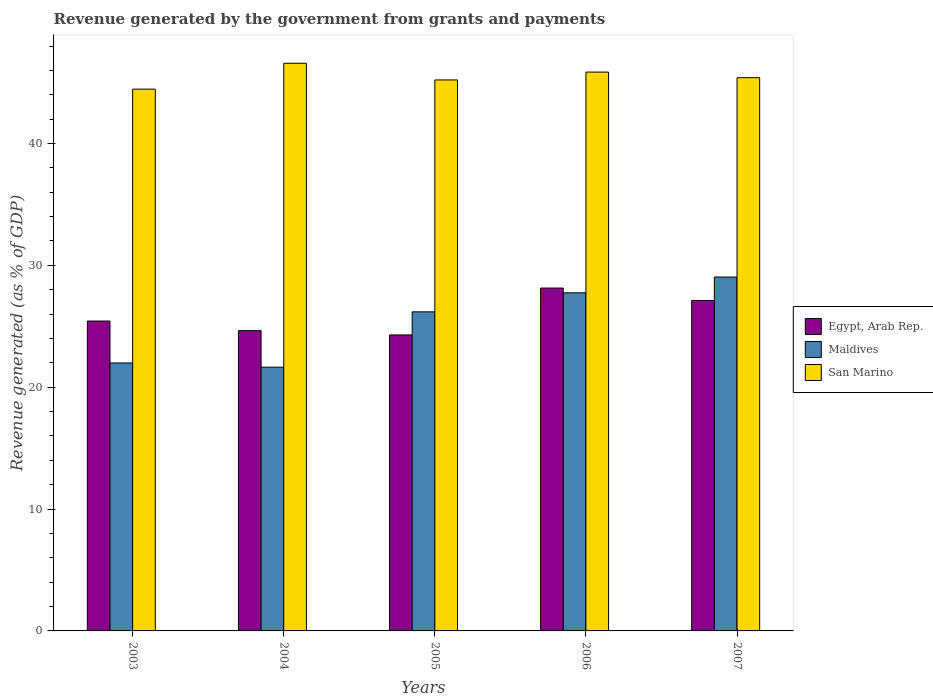Are the number of bars per tick equal to the number of legend labels?
Ensure brevity in your answer.  Yes. How many bars are there on the 5th tick from the left?
Your answer should be compact. 3. How many bars are there on the 5th tick from the right?
Provide a short and direct response. 3. What is the label of the 5th group of bars from the left?
Provide a short and direct response. 2007. In how many cases, is the number of bars for a given year not equal to the number of legend labels?
Give a very brief answer. 0. What is the revenue generated by the government in San Marino in 2007?
Ensure brevity in your answer.  45.4. Across all years, what is the maximum revenue generated by the government in Maldives?
Your answer should be compact. 29.04. Across all years, what is the minimum revenue generated by the government in San Marino?
Ensure brevity in your answer.  44.46. In which year was the revenue generated by the government in San Marino minimum?
Provide a succinct answer. 2003. What is the total revenue generated by the government in Egypt, Arab Rep. in the graph?
Provide a succinct answer. 129.62. What is the difference between the revenue generated by the government in Maldives in 2004 and that in 2005?
Your response must be concise. -4.54. What is the difference between the revenue generated by the government in San Marino in 2003 and the revenue generated by the government in Maldives in 2006?
Ensure brevity in your answer.  16.72. What is the average revenue generated by the government in Maldives per year?
Offer a very short reply. 25.32. In the year 2007, what is the difference between the revenue generated by the government in San Marino and revenue generated by the government in Maldives?
Your response must be concise. 16.36. What is the ratio of the revenue generated by the government in San Marino in 2005 to that in 2007?
Give a very brief answer. 1. What is the difference between the highest and the second highest revenue generated by the government in San Marino?
Ensure brevity in your answer.  0.72. What is the difference between the highest and the lowest revenue generated by the government in San Marino?
Provide a short and direct response. 2.12. What does the 2nd bar from the left in 2005 represents?
Offer a terse response. Maldives. What does the 2nd bar from the right in 2006 represents?
Give a very brief answer. Maldives. How many bars are there?
Give a very brief answer. 15. Are all the bars in the graph horizontal?
Offer a very short reply. No. Are the values on the major ticks of Y-axis written in scientific E-notation?
Offer a terse response. No. Does the graph contain grids?
Offer a very short reply. No. Where does the legend appear in the graph?
Your answer should be compact. Center right. How are the legend labels stacked?
Offer a very short reply. Vertical. What is the title of the graph?
Ensure brevity in your answer.  Revenue generated by the government from grants and payments. Does "Luxembourg" appear as one of the legend labels in the graph?
Offer a terse response. No. What is the label or title of the Y-axis?
Offer a very short reply. Revenue generated (as % of GDP). What is the Revenue generated (as % of GDP) of Egypt, Arab Rep. in 2003?
Your answer should be very brief. 25.43. What is the Revenue generated (as % of GDP) of Maldives in 2003?
Give a very brief answer. 21.99. What is the Revenue generated (as % of GDP) of San Marino in 2003?
Give a very brief answer. 44.46. What is the Revenue generated (as % of GDP) of Egypt, Arab Rep. in 2004?
Your answer should be compact. 24.64. What is the Revenue generated (as % of GDP) of Maldives in 2004?
Make the answer very short. 21.65. What is the Revenue generated (as % of GDP) in San Marino in 2004?
Provide a succinct answer. 46.59. What is the Revenue generated (as % of GDP) in Egypt, Arab Rep. in 2005?
Your answer should be compact. 24.29. What is the Revenue generated (as % of GDP) in Maldives in 2005?
Keep it short and to the point. 26.19. What is the Revenue generated (as % of GDP) in San Marino in 2005?
Provide a succinct answer. 45.22. What is the Revenue generated (as % of GDP) of Egypt, Arab Rep. in 2006?
Ensure brevity in your answer.  28.14. What is the Revenue generated (as % of GDP) of Maldives in 2006?
Your response must be concise. 27.75. What is the Revenue generated (as % of GDP) of San Marino in 2006?
Your answer should be very brief. 45.86. What is the Revenue generated (as % of GDP) in Egypt, Arab Rep. in 2007?
Provide a succinct answer. 27.12. What is the Revenue generated (as % of GDP) of Maldives in 2007?
Give a very brief answer. 29.04. What is the Revenue generated (as % of GDP) of San Marino in 2007?
Offer a very short reply. 45.4. Across all years, what is the maximum Revenue generated (as % of GDP) in Egypt, Arab Rep.?
Keep it short and to the point. 28.14. Across all years, what is the maximum Revenue generated (as % of GDP) in Maldives?
Offer a terse response. 29.04. Across all years, what is the maximum Revenue generated (as % of GDP) in San Marino?
Provide a succinct answer. 46.59. Across all years, what is the minimum Revenue generated (as % of GDP) in Egypt, Arab Rep.?
Provide a succinct answer. 24.29. Across all years, what is the minimum Revenue generated (as % of GDP) in Maldives?
Make the answer very short. 21.65. Across all years, what is the minimum Revenue generated (as % of GDP) in San Marino?
Offer a very short reply. 44.46. What is the total Revenue generated (as % of GDP) in Egypt, Arab Rep. in the graph?
Your answer should be very brief. 129.62. What is the total Revenue generated (as % of GDP) in Maldives in the graph?
Provide a succinct answer. 126.61. What is the total Revenue generated (as % of GDP) of San Marino in the graph?
Make the answer very short. 227.53. What is the difference between the Revenue generated (as % of GDP) of Egypt, Arab Rep. in 2003 and that in 2004?
Offer a very short reply. 0.79. What is the difference between the Revenue generated (as % of GDP) of Maldives in 2003 and that in 2004?
Your answer should be very brief. 0.34. What is the difference between the Revenue generated (as % of GDP) in San Marino in 2003 and that in 2004?
Ensure brevity in your answer.  -2.12. What is the difference between the Revenue generated (as % of GDP) of Egypt, Arab Rep. in 2003 and that in 2005?
Offer a terse response. 1.14. What is the difference between the Revenue generated (as % of GDP) of Maldives in 2003 and that in 2005?
Provide a short and direct response. -4.2. What is the difference between the Revenue generated (as % of GDP) of San Marino in 2003 and that in 2005?
Keep it short and to the point. -0.76. What is the difference between the Revenue generated (as % of GDP) of Egypt, Arab Rep. in 2003 and that in 2006?
Keep it short and to the point. -2.71. What is the difference between the Revenue generated (as % of GDP) of Maldives in 2003 and that in 2006?
Make the answer very short. -5.76. What is the difference between the Revenue generated (as % of GDP) in San Marino in 2003 and that in 2006?
Ensure brevity in your answer.  -1.4. What is the difference between the Revenue generated (as % of GDP) of Egypt, Arab Rep. in 2003 and that in 2007?
Keep it short and to the point. -1.69. What is the difference between the Revenue generated (as % of GDP) of Maldives in 2003 and that in 2007?
Offer a very short reply. -7.05. What is the difference between the Revenue generated (as % of GDP) in San Marino in 2003 and that in 2007?
Your answer should be very brief. -0.94. What is the difference between the Revenue generated (as % of GDP) of Egypt, Arab Rep. in 2004 and that in 2005?
Give a very brief answer. 0.35. What is the difference between the Revenue generated (as % of GDP) in Maldives in 2004 and that in 2005?
Offer a terse response. -4.54. What is the difference between the Revenue generated (as % of GDP) of San Marino in 2004 and that in 2005?
Your answer should be compact. 1.37. What is the difference between the Revenue generated (as % of GDP) of Egypt, Arab Rep. in 2004 and that in 2006?
Offer a very short reply. -3.5. What is the difference between the Revenue generated (as % of GDP) of Maldives in 2004 and that in 2006?
Provide a succinct answer. -6.1. What is the difference between the Revenue generated (as % of GDP) in San Marino in 2004 and that in 2006?
Offer a very short reply. 0.72. What is the difference between the Revenue generated (as % of GDP) in Egypt, Arab Rep. in 2004 and that in 2007?
Offer a very short reply. -2.48. What is the difference between the Revenue generated (as % of GDP) in Maldives in 2004 and that in 2007?
Keep it short and to the point. -7.4. What is the difference between the Revenue generated (as % of GDP) in San Marino in 2004 and that in 2007?
Make the answer very short. 1.18. What is the difference between the Revenue generated (as % of GDP) in Egypt, Arab Rep. in 2005 and that in 2006?
Give a very brief answer. -3.85. What is the difference between the Revenue generated (as % of GDP) of Maldives in 2005 and that in 2006?
Make the answer very short. -1.56. What is the difference between the Revenue generated (as % of GDP) in San Marino in 2005 and that in 2006?
Keep it short and to the point. -0.64. What is the difference between the Revenue generated (as % of GDP) in Egypt, Arab Rep. in 2005 and that in 2007?
Provide a short and direct response. -2.83. What is the difference between the Revenue generated (as % of GDP) in Maldives in 2005 and that in 2007?
Provide a succinct answer. -2.86. What is the difference between the Revenue generated (as % of GDP) of San Marino in 2005 and that in 2007?
Your answer should be very brief. -0.19. What is the difference between the Revenue generated (as % of GDP) of Egypt, Arab Rep. in 2006 and that in 2007?
Your response must be concise. 1.02. What is the difference between the Revenue generated (as % of GDP) of Maldives in 2006 and that in 2007?
Your response must be concise. -1.3. What is the difference between the Revenue generated (as % of GDP) in San Marino in 2006 and that in 2007?
Your response must be concise. 0.46. What is the difference between the Revenue generated (as % of GDP) in Egypt, Arab Rep. in 2003 and the Revenue generated (as % of GDP) in Maldives in 2004?
Your answer should be compact. 3.78. What is the difference between the Revenue generated (as % of GDP) of Egypt, Arab Rep. in 2003 and the Revenue generated (as % of GDP) of San Marino in 2004?
Give a very brief answer. -21.16. What is the difference between the Revenue generated (as % of GDP) in Maldives in 2003 and the Revenue generated (as % of GDP) in San Marino in 2004?
Your answer should be very brief. -24.6. What is the difference between the Revenue generated (as % of GDP) of Egypt, Arab Rep. in 2003 and the Revenue generated (as % of GDP) of Maldives in 2005?
Keep it short and to the point. -0.75. What is the difference between the Revenue generated (as % of GDP) in Egypt, Arab Rep. in 2003 and the Revenue generated (as % of GDP) in San Marino in 2005?
Keep it short and to the point. -19.79. What is the difference between the Revenue generated (as % of GDP) of Maldives in 2003 and the Revenue generated (as % of GDP) of San Marino in 2005?
Give a very brief answer. -23.23. What is the difference between the Revenue generated (as % of GDP) of Egypt, Arab Rep. in 2003 and the Revenue generated (as % of GDP) of Maldives in 2006?
Provide a succinct answer. -2.31. What is the difference between the Revenue generated (as % of GDP) of Egypt, Arab Rep. in 2003 and the Revenue generated (as % of GDP) of San Marino in 2006?
Give a very brief answer. -20.43. What is the difference between the Revenue generated (as % of GDP) in Maldives in 2003 and the Revenue generated (as % of GDP) in San Marino in 2006?
Your answer should be compact. -23.87. What is the difference between the Revenue generated (as % of GDP) of Egypt, Arab Rep. in 2003 and the Revenue generated (as % of GDP) of Maldives in 2007?
Offer a very short reply. -3.61. What is the difference between the Revenue generated (as % of GDP) of Egypt, Arab Rep. in 2003 and the Revenue generated (as % of GDP) of San Marino in 2007?
Offer a very short reply. -19.97. What is the difference between the Revenue generated (as % of GDP) of Maldives in 2003 and the Revenue generated (as % of GDP) of San Marino in 2007?
Ensure brevity in your answer.  -23.41. What is the difference between the Revenue generated (as % of GDP) of Egypt, Arab Rep. in 2004 and the Revenue generated (as % of GDP) of Maldives in 2005?
Your response must be concise. -1.54. What is the difference between the Revenue generated (as % of GDP) in Egypt, Arab Rep. in 2004 and the Revenue generated (as % of GDP) in San Marino in 2005?
Provide a succinct answer. -20.58. What is the difference between the Revenue generated (as % of GDP) in Maldives in 2004 and the Revenue generated (as % of GDP) in San Marino in 2005?
Ensure brevity in your answer.  -23.57. What is the difference between the Revenue generated (as % of GDP) of Egypt, Arab Rep. in 2004 and the Revenue generated (as % of GDP) of Maldives in 2006?
Your answer should be very brief. -3.11. What is the difference between the Revenue generated (as % of GDP) in Egypt, Arab Rep. in 2004 and the Revenue generated (as % of GDP) in San Marino in 2006?
Provide a short and direct response. -21.22. What is the difference between the Revenue generated (as % of GDP) in Maldives in 2004 and the Revenue generated (as % of GDP) in San Marino in 2006?
Provide a short and direct response. -24.22. What is the difference between the Revenue generated (as % of GDP) in Egypt, Arab Rep. in 2004 and the Revenue generated (as % of GDP) in Maldives in 2007?
Offer a very short reply. -4.4. What is the difference between the Revenue generated (as % of GDP) in Egypt, Arab Rep. in 2004 and the Revenue generated (as % of GDP) in San Marino in 2007?
Offer a terse response. -20.76. What is the difference between the Revenue generated (as % of GDP) in Maldives in 2004 and the Revenue generated (as % of GDP) in San Marino in 2007?
Your response must be concise. -23.76. What is the difference between the Revenue generated (as % of GDP) of Egypt, Arab Rep. in 2005 and the Revenue generated (as % of GDP) of Maldives in 2006?
Ensure brevity in your answer.  -3.45. What is the difference between the Revenue generated (as % of GDP) in Egypt, Arab Rep. in 2005 and the Revenue generated (as % of GDP) in San Marino in 2006?
Offer a very short reply. -21.57. What is the difference between the Revenue generated (as % of GDP) of Maldives in 2005 and the Revenue generated (as % of GDP) of San Marino in 2006?
Ensure brevity in your answer.  -19.68. What is the difference between the Revenue generated (as % of GDP) of Egypt, Arab Rep. in 2005 and the Revenue generated (as % of GDP) of Maldives in 2007?
Provide a short and direct response. -4.75. What is the difference between the Revenue generated (as % of GDP) in Egypt, Arab Rep. in 2005 and the Revenue generated (as % of GDP) in San Marino in 2007?
Keep it short and to the point. -21.11. What is the difference between the Revenue generated (as % of GDP) of Maldives in 2005 and the Revenue generated (as % of GDP) of San Marino in 2007?
Keep it short and to the point. -19.22. What is the difference between the Revenue generated (as % of GDP) in Egypt, Arab Rep. in 2006 and the Revenue generated (as % of GDP) in Maldives in 2007?
Ensure brevity in your answer.  -0.9. What is the difference between the Revenue generated (as % of GDP) in Egypt, Arab Rep. in 2006 and the Revenue generated (as % of GDP) in San Marino in 2007?
Provide a short and direct response. -17.26. What is the difference between the Revenue generated (as % of GDP) of Maldives in 2006 and the Revenue generated (as % of GDP) of San Marino in 2007?
Keep it short and to the point. -17.66. What is the average Revenue generated (as % of GDP) of Egypt, Arab Rep. per year?
Provide a short and direct response. 25.92. What is the average Revenue generated (as % of GDP) of Maldives per year?
Provide a short and direct response. 25.32. What is the average Revenue generated (as % of GDP) of San Marino per year?
Give a very brief answer. 45.51. In the year 2003, what is the difference between the Revenue generated (as % of GDP) in Egypt, Arab Rep. and Revenue generated (as % of GDP) in Maldives?
Provide a short and direct response. 3.44. In the year 2003, what is the difference between the Revenue generated (as % of GDP) in Egypt, Arab Rep. and Revenue generated (as % of GDP) in San Marino?
Provide a succinct answer. -19.03. In the year 2003, what is the difference between the Revenue generated (as % of GDP) in Maldives and Revenue generated (as % of GDP) in San Marino?
Ensure brevity in your answer.  -22.47. In the year 2004, what is the difference between the Revenue generated (as % of GDP) in Egypt, Arab Rep. and Revenue generated (as % of GDP) in Maldives?
Your answer should be compact. 2.99. In the year 2004, what is the difference between the Revenue generated (as % of GDP) in Egypt, Arab Rep. and Revenue generated (as % of GDP) in San Marino?
Give a very brief answer. -21.95. In the year 2004, what is the difference between the Revenue generated (as % of GDP) of Maldives and Revenue generated (as % of GDP) of San Marino?
Make the answer very short. -24.94. In the year 2005, what is the difference between the Revenue generated (as % of GDP) of Egypt, Arab Rep. and Revenue generated (as % of GDP) of Maldives?
Provide a succinct answer. -1.89. In the year 2005, what is the difference between the Revenue generated (as % of GDP) in Egypt, Arab Rep. and Revenue generated (as % of GDP) in San Marino?
Provide a succinct answer. -20.93. In the year 2005, what is the difference between the Revenue generated (as % of GDP) in Maldives and Revenue generated (as % of GDP) in San Marino?
Your response must be concise. -19.03. In the year 2006, what is the difference between the Revenue generated (as % of GDP) in Egypt, Arab Rep. and Revenue generated (as % of GDP) in Maldives?
Provide a short and direct response. 0.39. In the year 2006, what is the difference between the Revenue generated (as % of GDP) in Egypt, Arab Rep. and Revenue generated (as % of GDP) in San Marino?
Your answer should be very brief. -17.72. In the year 2006, what is the difference between the Revenue generated (as % of GDP) of Maldives and Revenue generated (as % of GDP) of San Marino?
Make the answer very short. -18.12. In the year 2007, what is the difference between the Revenue generated (as % of GDP) of Egypt, Arab Rep. and Revenue generated (as % of GDP) of Maldives?
Offer a terse response. -1.93. In the year 2007, what is the difference between the Revenue generated (as % of GDP) in Egypt, Arab Rep. and Revenue generated (as % of GDP) in San Marino?
Give a very brief answer. -18.29. In the year 2007, what is the difference between the Revenue generated (as % of GDP) of Maldives and Revenue generated (as % of GDP) of San Marino?
Your response must be concise. -16.36. What is the ratio of the Revenue generated (as % of GDP) of Egypt, Arab Rep. in 2003 to that in 2004?
Give a very brief answer. 1.03. What is the ratio of the Revenue generated (as % of GDP) in Maldives in 2003 to that in 2004?
Make the answer very short. 1.02. What is the ratio of the Revenue generated (as % of GDP) of San Marino in 2003 to that in 2004?
Provide a succinct answer. 0.95. What is the ratio of the Revenue generated (as % of GDP) of Egypt, Arab Rep. in 2003 to that in 2005?
Make the answer very short. 1.05. What is the ratio of the Revenue generated (as % of GDP) in Maldives in 2003 to that in 2005?
Offer a terse response. 0.84. What is the ratio of the Revenue generated (as % of GDP) of San Marino in 2003 to that in 2005?
Your answer should be very brief. 0.98. What is the ratio of the Revenue generated (as % of GDP) in Egypt, Arab Rep. in 2003 to that in 2006?
Give a very brief answer. 0.9. What is the ratio of the Revenue generated (as % of GDP) of Maldives in 2003 to that in 2006?
Ensure brevity in your answer.  0.79. What is the ratio of the Revenue generated (as % of GDP) of San Marino in 2003 to that in 2006?
Offer a terse response. 0.97. What is the ratio of the Revenue generated (as % of GDP) of Egypt, Arab Rep. in 2003 to that in 2007?
Give a very brief answer. 0.94. What is the ratio of the Revenue generated (as % of GDP) of Maldives in 2003 to that in 2007?
Your answer should be very brief. 0.76. What is the ratio of the Revenue generated (as % of GDP) in San Marino in 2003 to that in 2007?
Offer a terse response. 0.98. What is the ratio of the Revenue generated (as % of GDP) in Egypt, Arab Rep. in 2004 to that in 2005?
Ensure brevity in your answer.  1.01. What is the ratio of the Revenue generated (as % of GDP) of Maldives in 2004 to that in 2005?
Provide a succinct answer. 0.83. What is the ratio of the Revenue generated (as % of GDP) in San Marino in 2004 to that in 2005?
Ensure brevity in your answer.  1.03. What is the ratio of the Revenue generated (as % of GDP) of Egypt, Arab Rep. in 2004 to that in 2006?
Keep it short and to the point. 0.88. What is the ratio of the Revenue generated (as % of GDP) of Maldives in 2004 to that in 2006?
Offer a very short reply. 0.78. What is the ratio of the Revenue generated (as % of GDP) of San Marino in 2004 to that in 2006?
Ensure brevity in your answer.  1.02. What is the ratio of the Revenue generated (as % of GDP) in Egypt, Arab Rep. in 2004 to that in 2007?
Your response must be concise. 0.91. What is the ratio of the Revenue generated (as % of GDP) in Maldives in 2004 to that in 2007?
Your answer should be very brief. 0.75. What is the ratio of the Revenue generated (as % of GDP) in San Marino in 2004 to that in 2007?
Offer a terse response. 1.03. What is the ratio of the Revenue generated (as % of GDP) of Egypt, Arab Rep. in 2005 to that in 2006?
Your response must be concise. 0.86. What is the ratio of the Revenue generated (as % of GDP) of Maldives in 2005 to that in 2006?
Offer a very short reply. 0.94. What is the ratio of the Revenue generated (as % of GDP) in San Marino in 2005 to that in 2006?
Your response must be concise. 0.99. What is the ratio of the Revenue generated (as % of GDP) in Egypt, Arab Rep. in 2005 to that in 2007?
Keep it short and to the point. 0.9. What is the ratio of the Revenue generated (as % of GDP) in Maldives in 2005 to that in 2007?
Give a very brief answer. 0.9. What is the ratio of the Revenue generated (as % of GDP) of Egypt, Arab Rep. in 2006 to that in 2007?
Make the answer very short. 1.04. What is the ratio of the Revenue generated (as % of GDP) of Maldives in 2006 to that in 2007?
Keep it short and to the point. 0.96. What is the ratio of the Revenue generated (as % of GDP) of San Marino in 2006 to that in 2007?
Offer a terse response. 1.01. What is the difference between the highest and the second highest Revenue generated (as % of GDP) in Egypt, Arab Rep.?
Ensure brevity in your answer.  1.02. What is the difference between the highest and the second highest Revenue generated (as % of GDP) of Maldives?
Make the answer very short. 1.3. What is the difference between the highest and the second highest Revenue generated (as % of GDP) of San Marino?
Your response must be concise. 0.72. What is the difference between the highest and the lowest Revenue generated (as % of GDP) of Egypt, Arab Rep.?
Your answer should be very brief. 3.85. What is the difference between the highest and the lowest Revenue generated (as % of GDP) of Maldives?
Provide a succinct answer. 7.4. What is the difference between the highest and the lowest Revenue generated (as % of GDP) of San Marino?
Your answer should be compact. 2.12. 